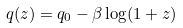Convert formula to latex. <formula><loc_0><loc_0><loc_500><loc_500>q ( z ) = q _ { 0 } - \beta \log ( 1 + z )</formula> 